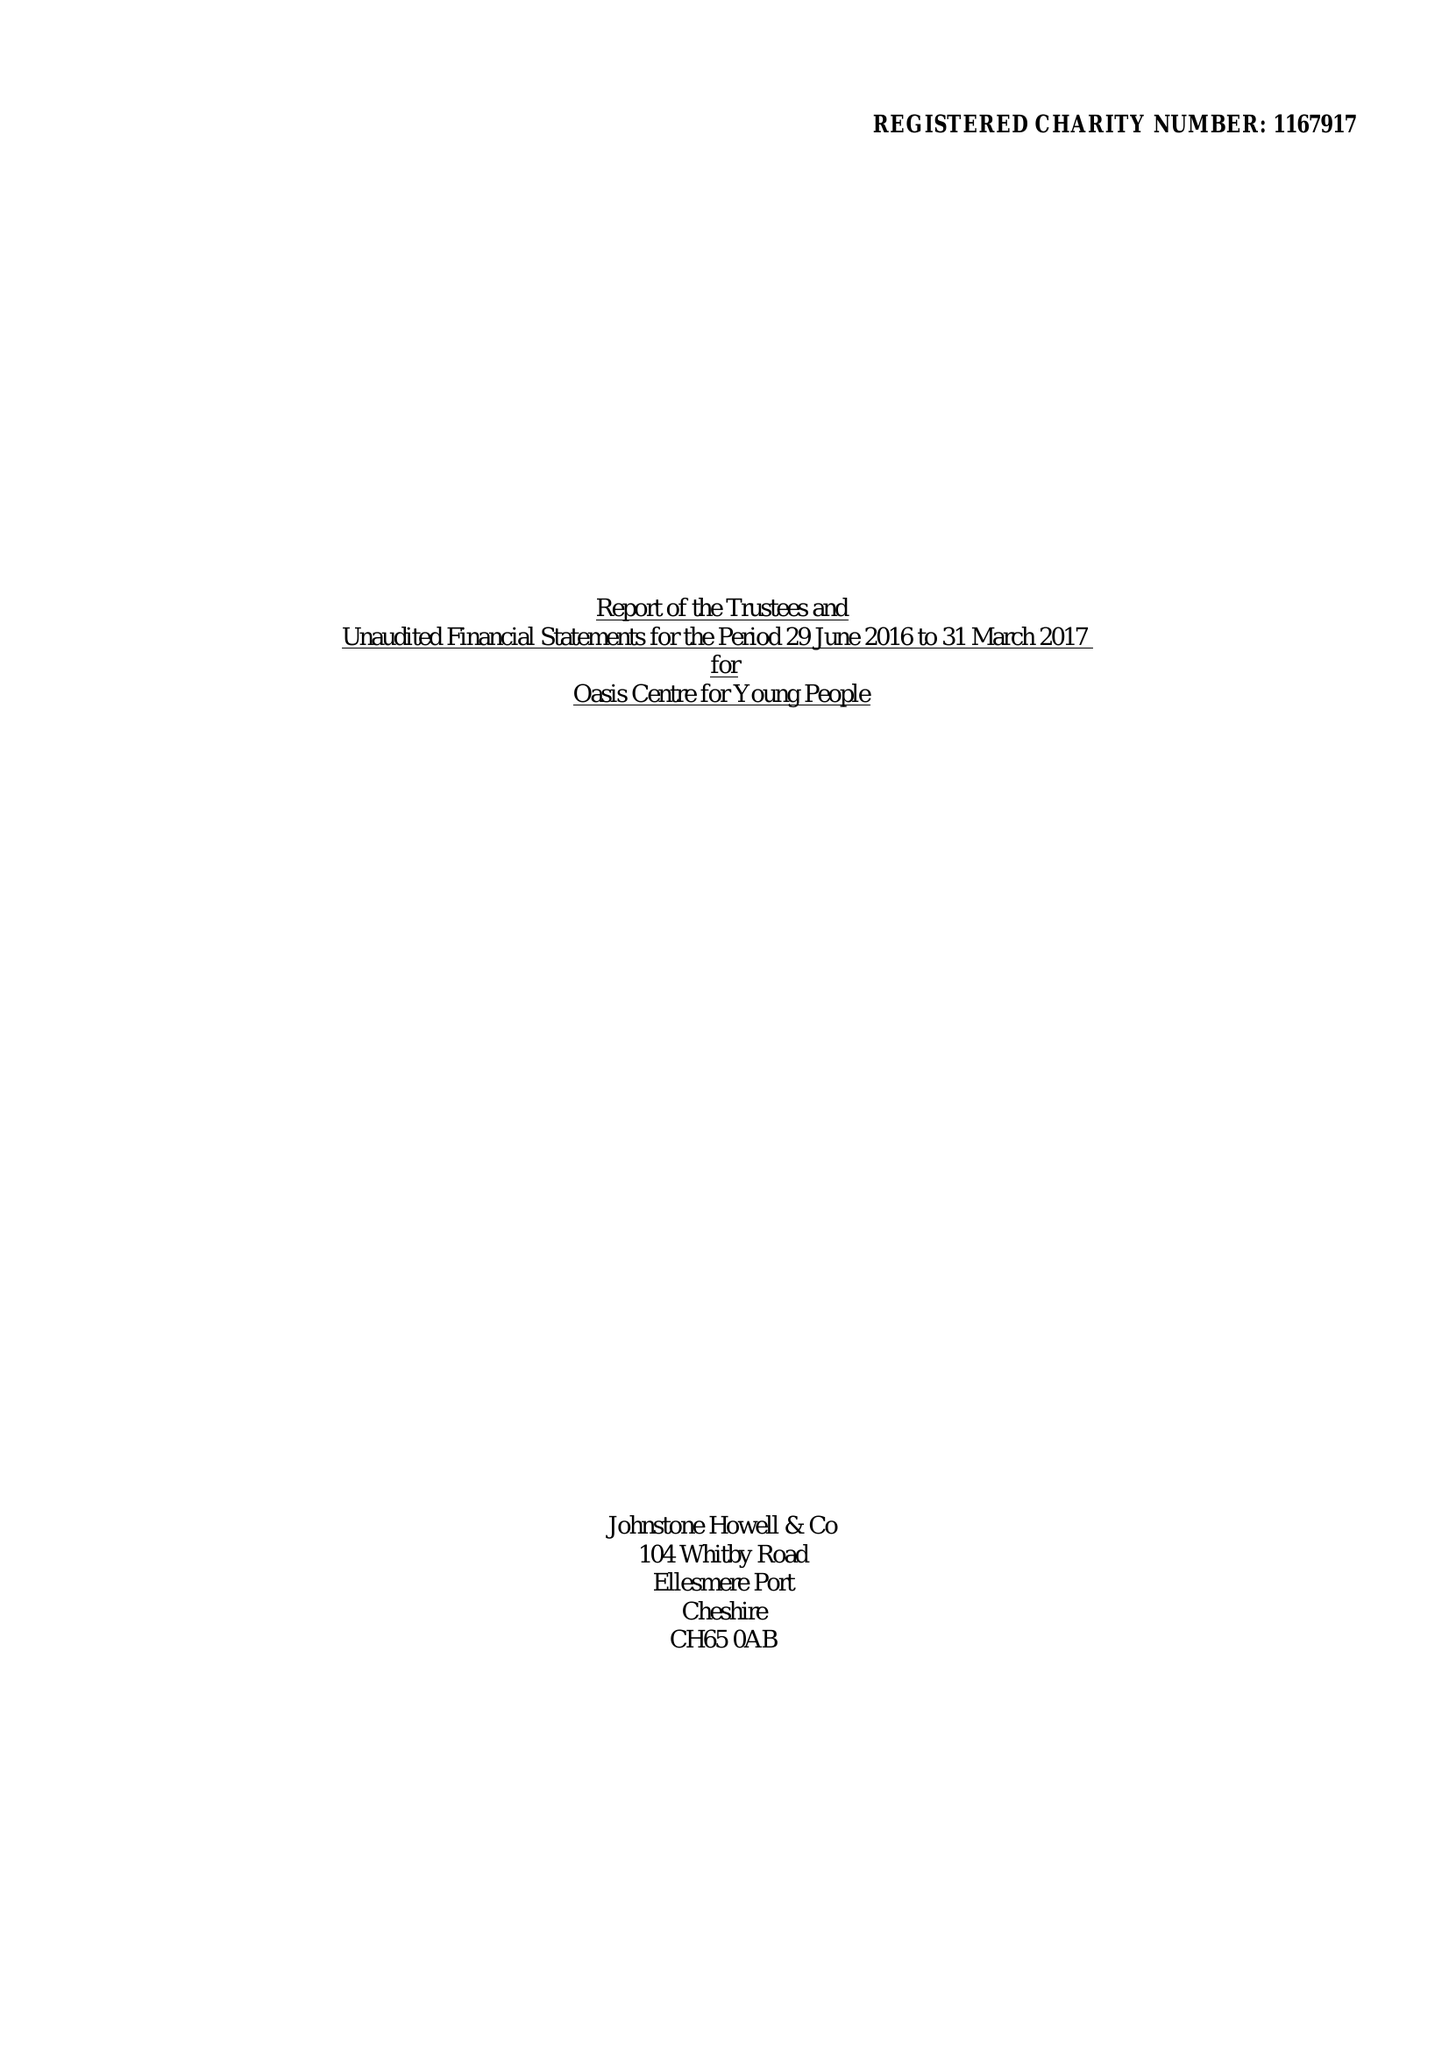What is the value for the address__post_town?
Answer the question using a single word or phrase. ELLESMERE PORT 